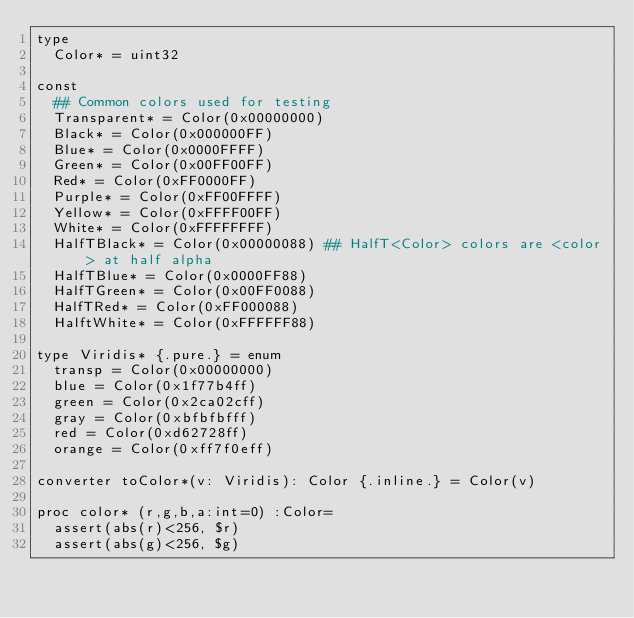Convert code to text. <code><loc_0><loc_0><loc_500><loc_500><_Nim_>type
  Color* = uint32
  
const
  ## Common colors used for testing
  Transparent* = Color(0x00000000)
  Black* = Color(0x000000FF)
  Blue* = Color(0x0000FFFF)
  Green* = Color(0x00FF00FF)
  Red* = Color(0xFF0000FF)
  Purple* = Color(0xFF00FFFF)
  Yellow* = Color(0xFFFF00FF)
  White* = Color(0xFFFFFFFF)
  HalfTBlack* = Color(0x00000088) ## HalfT<Color> colors are <color> at half alpha
  HalfTBlue* = Color(0x0000FF88)
  HalfTGreen* = Color(0x00FF0088)
  HalfTRed* = Color(0xFF000088)
  HalftWhite* = Color(0xFFFFFF88)

type Viridis* {.pure.} = enum
  transp = Color(0x00000000)
  blue = Color(0x1f77b4ff)
  green = Color(0x2ca02cff)
  gray = Color(0xbfbfbfff)
  red = Color(0xd62728ff)
  orange = Color(0xff7f0eff)

converter toColor*(v: Viridis): Color {.inline.} = Color(v)

proc color* (r,g,b,a:int=0) :Color=
  assert(abs(r)<256, $r)
  assert(abs(g)<256, $g)</code> 